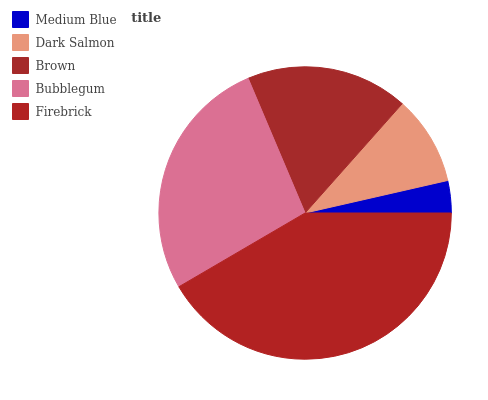Is Medium Blue the minimum?
Answer yes or no. Yes. Is Firebrick the maximum?
Answer yes or no. Yes. Is Dark Salmon the minimum?
Answer yes or no. No. Is Dark Salmon the maximum?
Answer yes or no. No. Is Dark Salmon greater than Medium Blue?
Answer yes or no. Yes. Is Medium Blue less than Dark Salmon?
Answer yes or no. Yes. Is Medium Blue greater than Dark Salmon?
Answer yes or no. No. Is Dark Salmon less than Medium Blue?
Answer yes or no. No. Is Brown the high median?
Answer yes or no. Yes. Is Brown the low median?
Answer yes or no. Yes. Is Dark Salmon the high median?
Answer yes or no. No. Is Firebrick the low median?
Answer yes or no. No. 